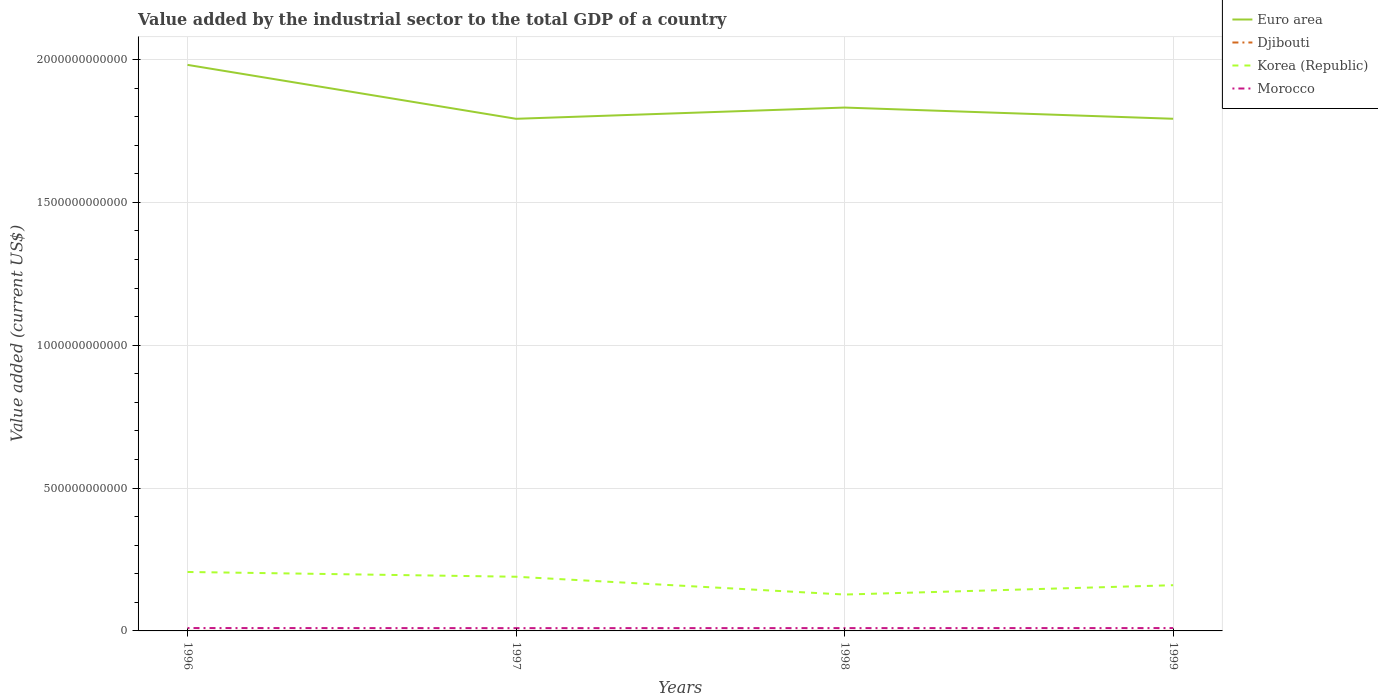How many different coloured lines are there?
Provide a short and direct response. 4. Is the number of lines equal to the number of legend labels?
Give a very brief answer. Yes. Across all years, what is the maximum value added by the industrial sector to the total GDP in Djibouti?
Make the answer very short. 6.64e+07. In which year was the value added by the industrial sector to the total GDP in Morocco maximum?
Your answer should be compact. 1997. What is the total value added by the industrial sector to the total GDP in Korea (Republic) in the graph?
Offer a terse response. 6.23e+1. What is the difference between the highest and the second highest value added by the industrial sector to the total GDP in Euro area?
Provide a succinct answer. 1.89e+11. Is the value added by the industrial sector to the total GDP in Morocco strictly greater than the value added by the industrial sector to the total GDP in Korea (Republic) over the years?
Offer a very short reply. Yes. What is the difference between two consecutive major ticks on the Y-axis?
Offer a terse response. 5.00e+11. Are the values on the major ticks of Y-axis written in scientific E-notation?
Ensure brevity in your answer.  No. Does the graph contain grids?
Provide a succinct answer. Yes. How are the legend labels stacked?
Provide a succinct answer. Vertical. What is the title of the graph?
Keep it short and to the point. Value added by the industrial sector to the total GDP of a country. Does "Chile" appear as one of the legend labels in the graph?
Your response must be concise. No. What is the label or title of the X-axis?
Offer a very short reply. Years. What is the label or title of the Y-axis?
Offer a terse response. Value added (current US$). What is the Value added (current US$) in Euro area in 1996?
Give a very brief answer. 1.98e+12. What is the Value added (current US$) in Djibouti in 1996?
Your answer should be compact. 6.64e+07. What is the Value added (current US$) of Korea (Republic) in 1996?
Make the answer very short. 2.06e+11. What is the Value added (current US$) in Morocco in 1996?
Ensure brevity in your answer.  1.00e+1. What is the Value added (current US$) of Euro area in 1997?
Provide a succinct answer. 1.79e+12. What is the Value added (current US$) in Djibouti in 1997?
Give a very brief answer. 6.69e+07. What is the Value added (current US$) in Korea (Republic) in 1997?
Provide a short and direct response. 1.90e+11. What is the Value added (current US$) in Morocco in 1997?
Provide a succinct answer. 9.73e+09. What is the Value added (current US$) in Euro area in 1998?
Offer a very short reply. 1.83e+12. What is the Value added (current US$) in Djibouti in 1998?
Give a very brief answer. 6.70e+07. What is the Value added (current US$) in Korea (Republic) in 1998?
Provide a succinct answer. 1.27e+11. What is the Value added (current US$) in Morocco in 1998?
Offer a very short reply. 9.83e+09. What is the Value added (current US$) of Euro area in 1999?
Ensure brevity in your answer.  1.79e+12. What is the Value added (current US$) of Djibouti in 1999?
Make the answer very short. 6.98e+07. What is the Value added (current US$) in Korea (Republic) in 1999?
Provide a succinct answer. 1.60e+11. What is the Value added (current US$) in Morocco in 1999?
Ensure brevity in your answer.  9.93e+09. Across all years, what is the maximum Value added (current US$) of Euro area?
Provide a short and direct response. 1.98e+12. Across all years, what is the maximum Value added (current US$) of Djibouti?
Make the answer very short. 6.98e+07. Across all years, what is the maximum Value added (current US$) in Korea (Republic)?
Ensure brevity in your answer.  2.06e+11. Across all years, what is the maximum Value added (current US$) of Morocco?
Your response must be concise. 1.00e+1. Across all years, what is the minimum Value added (current US$) in Euro area?
Ensure brevity in your answer.  1.79e+12. Across all years, what is the minimum Value added (current US$) of Djibouti?
Keep it short and to the point. 6.64e+07. Across all years, what is the minimum Value added (current US$) in Korea (Republic)?
Give a very brief answer. 1.27e+11. Across all years, what is the minimum Value added (current US$) in Morocco?
Provide a succinct answer. 9.73e+09. What is the total Value added (current US$) of Euro area in the graph?
Offer a very short reply. 7.40e+12. What is the total Value added (current US$) in Djibouti in the graph?
Ensure brevity in your answer.  2.70e+08. What is the total Value added (current US$) of Korea (Republic) in the graph?
Ensure brevity in your answer.  6.83e+11. What is the total Value added (current US$) in Morocco in the graph?
Keep it short and to the point. 3.95e+1. What is the difference between the Value added (current US$) in Euro area in 1996 and that in 1997?
Your answer should be very brief. 1.89e+11. What is the difference between the Value added (current US$) of Djibouti in 1996 and that in 1997?
Give a very brief answer. -4.45e+05. What is the difference between the Value added (current US$) of Korea (Republic) in 1996 and that in 1997?
Your answer should be very brief. 1.67e+1. What is the difference between the Value added (current US$) of Morocco in 1996 and that in 1997?
Give a very brief answer. 2.96e+08. What is the difference between the Value added (current US$) of Euro area in 1996 and that in 1998?
Offer a terse response. 1.49e+11. What is the difference between the Value added (current US$) in Djibouti in 1996 and that in 1998?
Provide a short and direct response. -6.02e+05. What is the difference between the Value added (current US$) in Korea (Republic) in 1996 and that in 1998?
Your response must be concise. 7.90e+1. What is the difference between the Value added (current US$) of Morocco in 1996 and that in 1998?
Your response must be concise. 1.91e+08. What is the difference between the Value added (current US$) in Euro area in 1996 and that in 1999?
Keep it short and to the point. 1.89e+11. What is the difference between the Value added (current US$) of Djibouti in 1996 and that in 1999?
Keep it short and to the point. -3.35e+06. What is the difference between the Value added (current US$) in Korea (Republic) in 1996 and that in 1999?
Your response must be concise. 4.63e+1. What is the difference between the Value added (current US$) of Morocco in 1996 and that in 1999?
Keep it short and to the point. 9.06e+07. What is the difference between the Value added (current US$) of Euro area in 1997 and that in 1998?
Give a very brief answer. -3.93e+1. What is the difference between the Value added (current US$) of Djibouti in 1997 and that in 1998?
Give a very brief answer. -1.58e+05. What is the difference between the Value added (current US$) of Korea (Republic) in 1997 and that in 1998?
Your response must be concise. 6.23e+1. What is the difference between the Value added (current US$) of Morocco in 1997 and that in 1998?
Make the answer very short. -1.05e+08. What is the difference between the Value added (current US$) in Euro area in 1997 and that in 1999?
Your answer should be compact. -1.22e+08. What is the difference between the Value added (current US$) in Djibouti in 1997 and that in 1999?
Offer a very short reply. -2.90e+06. What is the difference between the Value added (current US$) of Korea (Republic) in 1997 and that in 1999?
Offer a terse response. 2.96e+1. What is the difference between the Value added (current US$) in Morocco in 1997 and that in 1999?
Offer a terse response. -2.05e+08. What is the difference between the Value added (current US$) of Euro area in 1998 and that in 1999?
Your answer should be very brief. 3.92e+1. What is the difference between the Value added (current US$) in Djibouti in 1998 and that in 1999?
Provide a short and direct response. -2.75e+06. What is the difference between the Value added (current US$) in Korea (Republic) in 1998 and that in 1999?
Provide a short and direct response. -3.27e+1. What is the difference between the Value added (current US$) of Morocco in 1998 and that in 1999?
Provide a succinct answer. -1.01e+08. What is the difference between the Value added (current US$) in Euro area in 1996 and the Value added (current US$) in Djibouti in 1997?
Give a very brief answer. 1.98e+12. What is the difference between the Value added (current US$) of Euro area in 1996 and the Value added (current US$) of Korea (Republic) in 1997?
Your answer should be very brief. 1.79e+12. What is the difference between the Value added (current US$) in Euro area in 1996 and the Value added (current US$) in Morocco in 1997?
Your answer should be very brief. 1.97e+12. What is the difference between the Value added (current US$) of Djibouti in 1996 and the Value added (current US$) of Korea (Republic) in 1997?
Give a very brief answer. -1.90e+11. What is the difference between the Value added (current US$) of Djibouti in 1996 and the Value added (current US$) of Morocco in 1997?
Provide a short and direct response. -9.66e+09. What is the difference between the Value added (current US$) of Korea (Republic) in 1996 and the Value added (current US$) of Morocco in 1997?
Make the answer very short. 1.97e+11. What is the difference between the Value added (current US$) in Euro area in 1996 and the Value added (current US$) in Djibouti in 1998?
Ensure brevity in your answer.  1.98e+12. What is the difference between the Value added (current US$) of Euro area in 1996 and the Value added (current US$) of Korea (Republic) in 1998?
Your answer should be compact. 1.85e+12. What is the difference between the Value added (current US$) in Euro area in 1996 and the Value added (current US$) in Morocco in 1998?
Offer a very short reply. 1.97e+12. What is the difference between the Value added (current US$) of Djibouti in 1996 and the Value added (current US$) of Korea (Republic) in 1998?
Offer a very short reply. -1.27e+11. What is the difference between the Value added (current US$) in Djibouti in 1996 and the Value added (current US$) in Morocco in 1998?
Offer a very short reply. -9.77e+09. What is the difference between the Value added (current US$) in Korea (Republic) in 1996 and the Value added (current US$) in Morocco in 1998?
Your answer should be compact. 1.97e+11. What is the difference between the Value added (current US$) of Euro area in 1996 and the Value added (current US$) of Djibouti in 1999?
Provide a succinct answer. 1.98e+12. What is the difference between the Value added (current US$) in Euro area in 1996 and the Value added (current US$) in Korea (Republic) in 1999?
Your answer should be compact. 1.82e+12. What is the difference between the Value added (current US$) of Euro area in 1996 and the Value added (current US$) of Morocco in 1999?
Ensure brevity in your answer.  1.97e+12. What is the difference between the Value added (current US$) in Djibouti in 1996 and the Value added (current US$) in Korea (Republic) in 1999?
Give a very brief answer. -1.60e+11. What is the difference between the Value added (current US$) of Djibouti in 1996 and the Value added (current US$) of Morocco in 1999?
Offer a terse response. -9.87e+09. What is the difference between the Value added (current US$) of Korea (Republic) in 1996 and the Value added (current US$) of Morocco in 1999?
Keep it short and to the point. 1.96e+11. What is the difference between the Value added (current US$) in Euro area in 1997 and the Value added (current US$) in Djibouti in 1998?
Keep it short and to the point. 1.79e+12. What is the difference between the Value added (current US$) in Euro area in 1997 and the Value added (current US$) in Korea (Republic) in 1998?
Ensure brevity in your answer.  1.67e+12. What is the difference between the Value added (current US$) in Euro area in 1997 and the Value added (current US$) in Morocco in 1998?
Give a very brief answer. 1.78e+12. What is the difference between the Value added (current US$) in Djibouti in 1997 and the Value added (current US$) in Korea (Republic) in 1998?
Provide a succinct answer. -1.27e+11. What is the difference between the Value added (current US$) in Djibouti in 1997 and the Value added (current US$) in Morocco in 1998?
Your response must be concise. -9.76e+09. What is the difference between the Value added (current US$) in Korea (Republic) in 1997 and the Value added (current US$) in Morocco in 1998?
Your answer should be very brief. 1.80e+11. What is the difference between the Value added (current US$) of Euro area in 1997 and the Value added (current US$) of Djibouti in 1999?
Ensure brevity in your answer.  1.79e+12. What is the difference between the Value added (current US$) of Euro area in 1997 and the Value added (current US$) of Korea (Republic) in 1999?
Offer a terse response. 1.63e+12. What is the difference between the Value added (current US$) of Euro area in 1997 and the Value added (current US$) of Morocco in 1999?
Offer a very short reply. 1.78e+12. What is the difference between the Value added (current US$) in Djibouti in 1997 and the Value added (current US$) in Korea (Republic) in 1999?
Your answer should be very brief. -1.60e+11. What is the difference between the Value added (current US$) of Djibouti in 1997 and the Value added (current US$) of Morocco in 1999?
Offer a very short reply. -9.87e+09. What is the difference between the Value added (current US$) of Korea (Republic) in 1997 and the Value added (current US$) of Morocco in 1999?
Your answer should be very brief. 1.80e+11. What is the difference between the Value added (current US$) of Euro area in 1998 and the Value added (current US$) of Djibouti in 1999?
Ensure brevity in your answer.  1.83e+12. What is the difference between the Value added (current US$) in Euro area in 1998 and the Value added (current US$) in Korea (Republic) in 1999?
Keep it short and to the point. 1.67e+12. What is the difference between the Value added (current US$) in Euro area in 1998 and the Value added (current US$) in Morocco in 1999?
Your response must be concise. 1.82e+12. What is the difference between the Value added (current US$) in Djibouti in 1998 and the Value added (current US$) in Korea (Republic) in 1999?
Make the answer very short. -1.60e+11. What is the difference between the Value added (current US$) in Djibouti in 1998 and the Value added (current US$) in Morocco in 1999?
Your response must be concise. -9.87e+09. What is the difference between the Value added (current US$) of Korea (Republic) in 1998 and the Value added (current US$) of Morocco in 1999?
Your answer should be very brief. 1.17e+11. What is the average Value added (current US$) of Euro area per year?
Offer a very short reply. 1.85e+12. What is the average Value added (current US$) of Djibouti per year?
Your answer should be very brief. 6.75e+07. What is the average Value added (current US$) of Korea (Republic) per year?
Your answer should be compact. 1.71e+11. What is the average Value added (current US$) in Morocco per year?
Offer a terse response. 9.88e+09. In the year 1996, what is the difference between the Value added (current US$) of Euro area and Value added (current US$) of Djibouti?
Keep it short and to the point. 1.98e+12. In the year 1996, what is the difference between the Value added (current US$) of Euro area and Value added (current US$) of Korea (Republic)?
Give a very brief answer. 1.77e+12. In the year 1996, what is the difference between the Value added (current US$) of Euro area and Value added (current US$) of Morocco?
Give a very brief answer. 1.97e+12. In the year 1996, what is the difference between the Value added (current US$) in Djibouti and Value added (current US$) in Korea (Republic)?
Offer a terse response. -2.06e+11. In the year 1996, what is the difference between the Value added (current US$) of Djibouti and Value added (current US$) of Morocco?
Keep it short and to the point. -9.96e+09. In the year 1996, what is the difference between the Value added (current US$) of Korea (Republic) and Value added (current US$) of Morocco?
Your answer should be compact. 1.96e+11. In the year 1997, what is the difference between the Value added (current US$) of Euro area and Value added (current US$) of Djibouti?
Ensure brevity in your answer.  1.79e+12. In the year 1997, what is the difference between the Value added (current US$) of Euro area and Value added (current US$) of Korea (Republic)?
Offer a very short reply. 1.60e+12. In the year 1997, what is the difference between the Value added (current US$) in Euro area and Value added (current US$) in Morocco?
Your answer should be compact. 1.78e+12. In the year 1997, what is the difference between the Value added (current US$) in Djibouti and Value added (current US$) in Korea (Republic)?
Provide a succinct answer. -1.90e+11. In the year 1997, what is the difference between the Value added (current US$) of Djibouti and Value added (current US$) of Morocco?
Give a very brief answer. -9.66e+09. In the year 1997, what is the difference between the Value added (current US$) of Korea (Republic) and Value added (current US$) of Morocco?
Your answer should be compact. 1.80e+11. In the year 1998, what is the difference between the Value added (current US$) of Euro area and Value added (current US$) of Djibouti?
Offer a terse response. 1.83e+12. In the year 1998, what is the difference between the Value added (current US$) of Euro area and Value added (current US$) of Korea (Republic)?
Provide a succinct answer. 1.70e+12. In the year 1998, what is the difference between the Value added (current US$) in Euro area and Value added (current US$) in Morocco?
Give a very brief answer. 1.82e+12. In the year 1998, what is the difference between the Value added (current US$) in Djibouti and Value added (current US$) in Korea (Republic)?
Provide a short and direct response. -1.27e+11. In the year 1998, what is the difference between the Value added (current US$) of Djibouti and Value added (current US$) of Morocco?
Offer a very short reply. -9.76e+09. In the year 1998, what is the difference between the Value added (current US$) of Korea (Republic) and Value added (current US$) of Morocco?
Make the answer very short. 1.18e+11. In the year 1999, what is the difference between the Value added (current US$) in Euro area and Value added (current US$) in Djibouti?
Your answer should be compact. 1.79e+12. In the year 1999, what is the difference between the Value added (current US$) in Euro area and Value added (current US$) in Korea (Republic)?
Ensure brevity in your answer.  1.63e+12. In the year 1999, what is the difference between the Value added (current US$) in Euro area and Value added (current US$) in Morocco?
Give a very brief answer. 1.78e+12. In the year 1999, what is the difference between the Value added (current US$) in Djibouti and Value added (current US$) in Korea (Republic)?
Your answer should be compact. -1.60e+11. In the year 1999, what is the difference between the Value added (current US$) of Djibouti and Value added (current US$) of Morocco?
Provide a short and direct response. -9.86e+09. In the year 1999, what is the difference between the Value added (current US$) in Korea (Republic) and Value added (current US$) in Morocco?
Provide a succinct answer. 1.50e+11. What is the ratio of the Value added (current US$) of Euro area in 1996 to that in 1997?
Offer a very short reply. 1.11. What is the ratio of the Value added (current US$) of Djibouti in 1996 to that in 1997?
Keep it short and to the point. 0.99. What is the ratio of the Value added (current US$) in Korea (Republic) in 1996 to that in 1997?
Your answer should be compact. 1.09. What is the ratio of the Value added (current US$) of Morocco in 1996 to that in 1997?
Provide a succinct answer. 1.03. What is the ratio of the Value added (current US$) in Euro area in 1996 to that in 1998?
Your answer should be very brief. 1.08. What is the ratio of the Value added (current US$) of Korea (Republic) in 1996 to that in 1998?
Your response must be concise. 1.62. What is the ratio of the Value added (current US$) of Morocco in 1996 to that in 1998?
Offer a very short reply. 1.02. What is the ratio of the Value added (current US$) of Euro area in 1996 to that in 1999?
Ensure brevity in your answer.  1.11. What is the ratio of the Value added (current US$) of Korea (Republic) in 1996 to that in 1999?
Your answer should be very brief. 1.29. What is the ratio of the Value added (current US$) in Morocco in 1996 to that in 1999?
Ensure brevity in your answer.  1.01. What is the ratio of the Value added (current US$) in Euro area in 1997 to that in 1998?
Keep it short and to the point. 0.98. What is the ratio of the Value added (current US$) in Korea (Republic) in 1997 to that in 1998?
Provide a short and direct response. 1.49. What is the ratio of the Value added (current US$) in Djibouti in 1997 to that in 1999?
Offer a terse response. 0.96. What is the ratio of the Value added (current US$) in Korea (Republic) in 1997 to that in 1999?
Offer a terse response. 1.19. What is the ratio of the Value added (current US$) in Morocco in 1997 to that in 1999?
Keep it short and to the point. 0.98. What is the ratio of the Value added (current US$) of Euro area in 1998 to that in 1999?
Your response must be concise. 1.02. What is the ratio of the Value added (current US$) in Djibouti in 1998 to that in 1999?
Ensure brevity in your answer.  0.96. What is the ratio of the Value added (current US$) of Korea (Republic) in 1998 to that in 1999?
Provide a short and direct response. 0.8. What is the ratio of the Value added (current US$) in Morocco in 1998 to that in 1999?
Your answer should be compact. 0.99. What is the difference between the highest and the second highest Value added (current US$) in Euro area?
Your answer should be very brief. 1.49e+11. What is the difference between the highest and the second highest Value added (current US$) of Djibouti?
Provide a succinct answer. 2.75e+06. What is the difference between the highest and the second highest Value added (current US$) of Korea (Republic)?
Ensure brevity in your answer.  1.67e+1. What is the difference between the highest and the second highest Value added (current US$) in Morocco?
Give a very brief answer. 9.06e+07. What is the difference between the highest and the lowest Value added (current US$) in Euro area?
Make the answer very short. 1.89e+11. What is the difference between the highest and the lowest Value added (current US$) of Djibouti?
Your answer should be compact. 3.35e+06. What is the difference between the highest and the lowest Value added (current US$) of Korea (Republic)?
Offer a very short reply. 7.90e+1. What is the difference between the highest and the lowest Value added (current US$) in Morocco?
Your answer should be compact. 2.96e+08. 